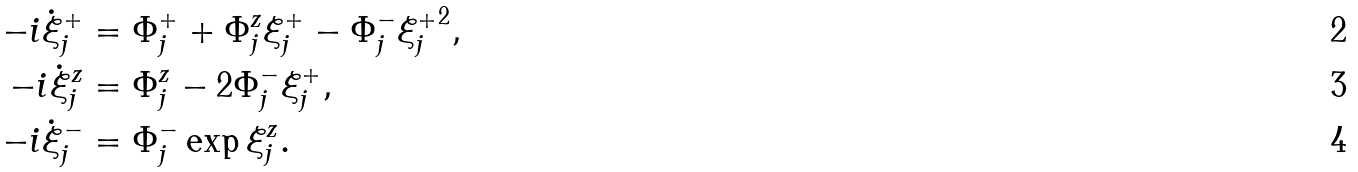Convert formula to latex. <formula><loc_0><loc_0><loc_500><loc_500>- i \dot { \xi } ^ { + } _ { j } & = \Phi ^ { + } _ { j } + \Phi ^ { z } _ { j } \xi ^ { + } _ { j } - \Phi ^ { - } _ { j } { \xi ^ { + } _ { j } } ^ { 2 } , \\ - i \dot { \xi } ^ { z } _ { j } & = \Phi ^ { z } _ { j } - 2 \Phi ^ { - } _ { j } \xi ^ { + } _ { j } , \\ - i \dot { \xi } ^ { - } _ { j } & = \Phi ^ { - } _ { j } \exp { \xi ^ { z } _ { j } } .</formula> 